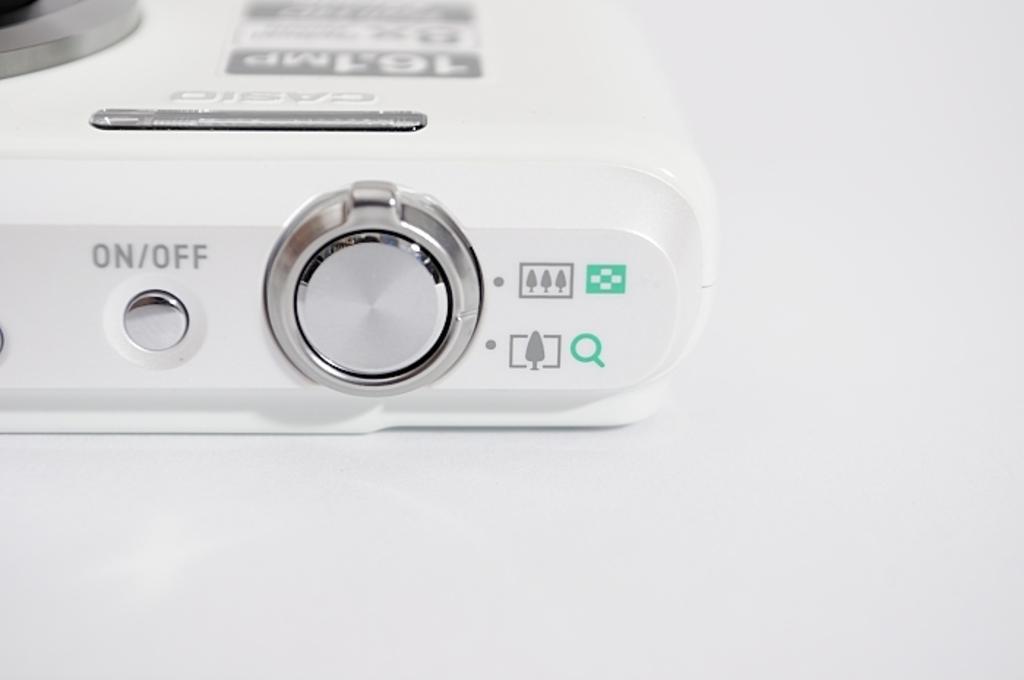What does the little button on the top do?
Your answer should be very brief. On/off. The button on the left can turn on the machine?
Your answer should be very brief. Yes. 